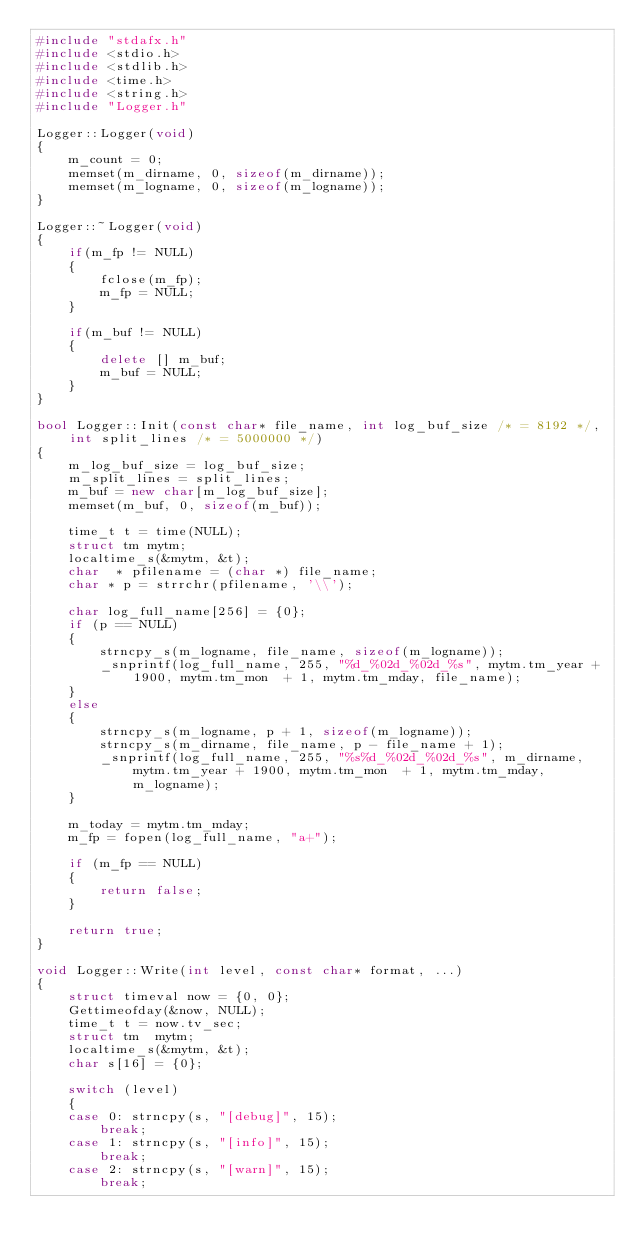Convert code to text. <code><loc_0><loc_0><loc_500><loc_500><_C++_>#include "stdafx.h"
#include <stdio.h>
#include <stdlib.h>
#include <time.h>
#include <string.h>
#include "Logger.h"

Logger::Logger(void)
{
	m_count = 0;
	memset(m_dirname, 0, sizeof(m_dirname));
	memset(m_logname, 0, sizeof(m_logname));
}

Logger::~Logger(void)
{
	if(m_fp != NULL)
	{
		fclose(m_fp);
		m_fp = NULL;
	}

	if(m_buf != NULL)
	{
		delete [] m_buf;
		m_buf = NULL;
	}
}

bool Logger::Init(const char* file_name, int log_buf_size /* = 8192 */, int split_lines /* = 5000000 */)
{
	m_log_buf_size = log_buf_size;
	m_split_lines = split_lines;
	m_buf = new char[m_log_buf_size];
	memset(m_buf, 0, sizeof(m_buf));

	time_t t = time(NULL);
	struct tm mytm;
	localtime_s(&mytm, &t);
	char  * pfilename = (char *) file_name;
	char * p = strrchr(pfilename, '\\');

	char log_full_name[256] = {0};
	if (p == NULL)
	{
		strncpy_s(m_logname, file_name, sizeof(m_logname));
		_snprintf(log_full_name, 255, "%d_%02d_%02d_%s", mytm.tm_year + 1900, mytm.tm_mon  + 1, mytm.tm_mday, file_name);
	}
	else
	{
		strncpy_s(m_logname, p + 1, sizeof(m_logname));
		strncpy_s(m_dirname, file_name, p - file_name + 1);
		_snprintf(log_full_name, 255, "%s%d_%02d_%02d_%s", m_dirname, mytm.tm_year + 1900, mytm.tm_mon  + 1, mytm.tm_mday, m_logname);
	}

	m_today = mytm.tm_mday;
	m_fp = fopen(log_full_name, "a+");

	if (m_fp == NULL)
	{
		return false;
	}

	return true;
}

void Logger::Write(int level, const char* format, ...)
{
	struct timeval now = {0, 0};
	Gettimeofday(&now, NULL);
	time_t t = now.tv_sec;
	struct tm  mytm;
	localtime_s(&mytm, &t);
	char s[16] = {0};

	switch (level)
	{
	case 0: strncpy(s, "[debug]", 15);
		break;
	case 1: strncpy(s, "[info]", 15);
		break;
	case 2: strncpy(s, "[warn]", 15);
		break;</code> 